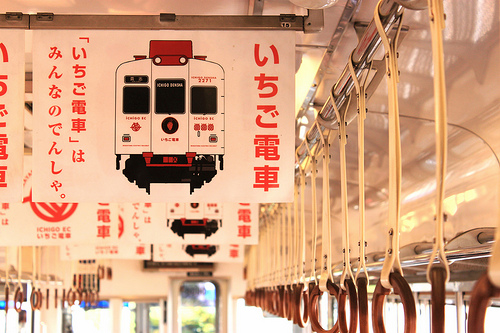<image>
Can you confirm if the train sign is in front of the window? Yes. The train sign is positioned in front of the window, appearing closer to the camera viewpoint. 